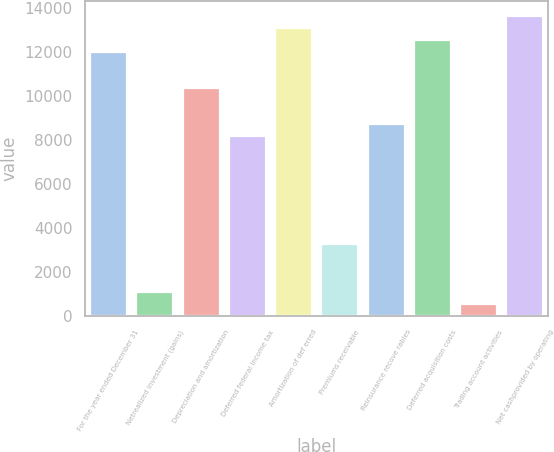Convert chart to OTSL. <chart><loc_0><loc_0><loc_500><loc_500><bar_chart><fcel>For the year ended December 31<fcel>Netrealized investment (gains)<fcel>Depreciation and amortization<fcel>Deferred federal income tax<fcel>Amortization of def erred<fcel>Premiums receivable<fcel>Reinsurance recove rables<fcel>Deferred acquisition costs<fcel>Trading account activities<fcel>Net cashprovided by operating<nl><fcel>11995<fcel>1095<fcel>10360<fcel>8180<fcel>13085<fcel>3275<fcel>8725<fcel>12540<fcel>550<fcel>13630<nl></chart> 